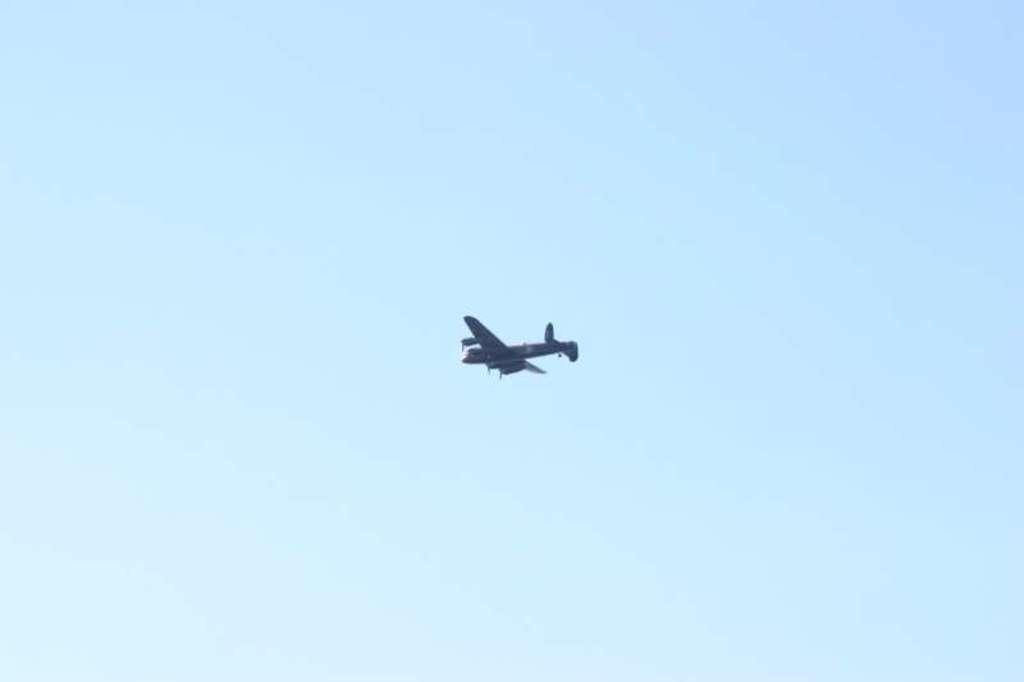Describe this image in one or two sentences. In this picture there is an aircraft in the center of the image. 